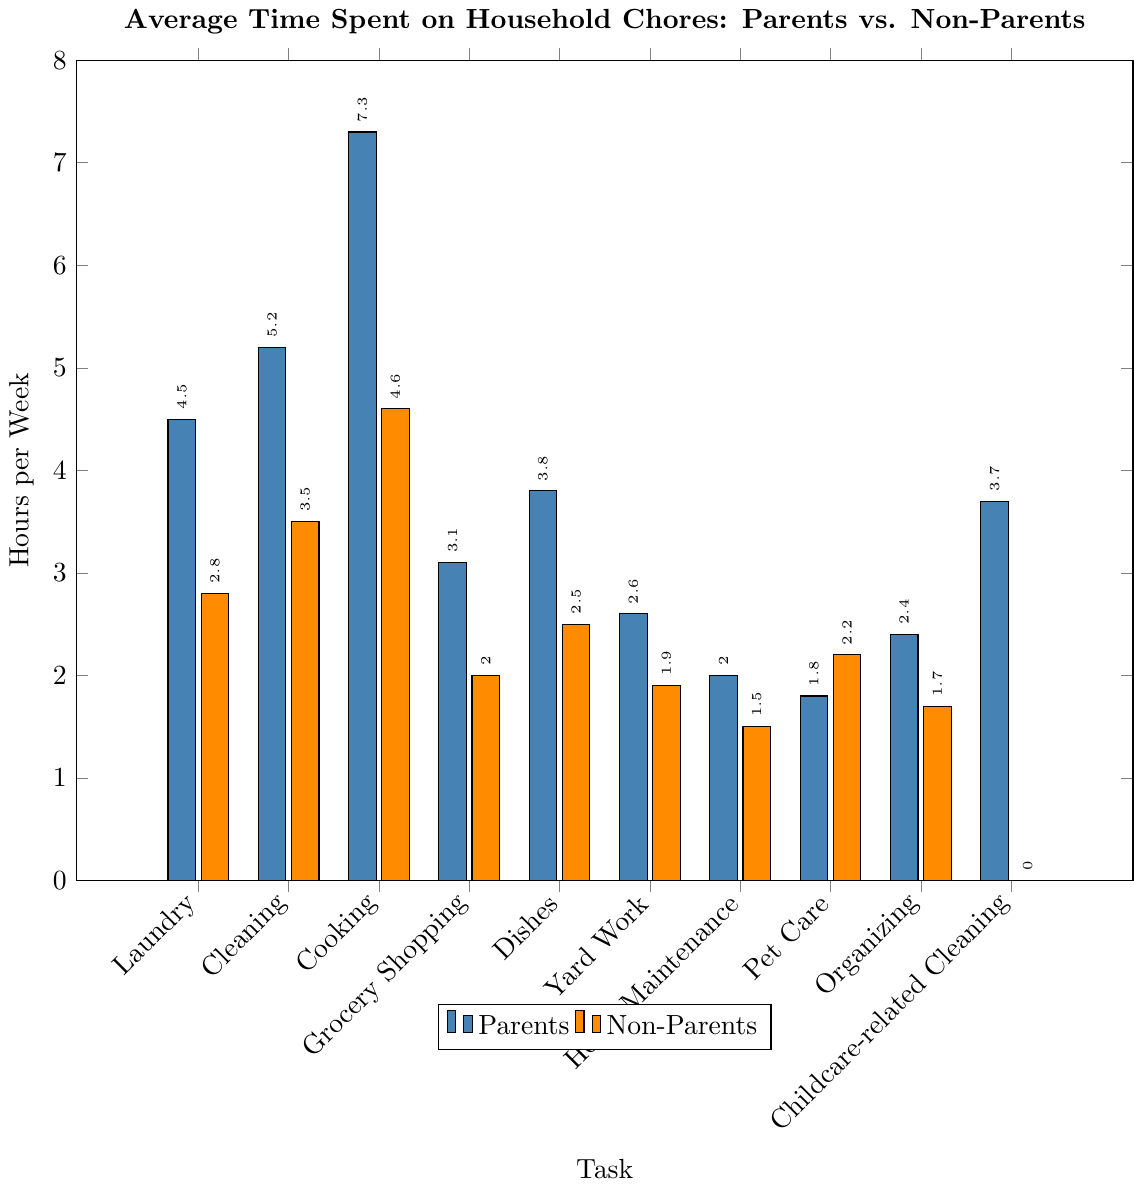Which task has the highest average time spent by parents? By looking at the figure, the bar for cooking among parents has the greatest height compared to other tasks.
Answer: Cooking What is the difference in time spent on laundry between parents and non-parents? The figure shows that parents spend 4.5 hours per week, and non-parents spend 2.8 hours per week on laundry. The difference is 4.5 - 2.8 = 1.7 hours.
Answer: 1.7 hours Which tasks do non-parents spend more time on than parents? By comparing the heights of the bars, it is observed that non-parents spend more time on pet care compared to parents.
Answer: Pet care How much more time do parents spend on cleaning compared to non-parents? The time spent on cleaning by parents is 5.2 hours and by non-parents is 3.5 hours. The difference is 5.2 - 3.5 = 1.7 hours.
Answer: 1.7 hours Which group spends more time on dishes, and by how much? The figure shows that parents spend 3.8 hours on dishes, while non-parents spend 2.5 hours. The difference is 3.8 - 2.5 = 1.3 hours, showing that parents spend more time.
Answer: Parents by 1.3 hours Total time spent by parents on all tasks except pet care and childcare-related cleaning? Adding the hours for all tasks except pet care and childcare-related cleaning: 4.5 (laundry) + 5.2 (cleaning) + 7.3 (cooking) + 3.1 (grocery shopping) + 3.8 (dishes) + 2.6 (yard work) + 2.0 (home maintenance) + 2.4 (organizing) = 30.9 hours.
Answer: 30.9 hours Which group spends less time on home maintenance, and what's the exact difference? From the figure, parents spend 2.0 hours and non-parents spend 1.5 hours on home maintenance. Parents spend more; the difference is 2.0 - 1.5 = 0.5 hours.
Answer: Non-parents by 0.5 hours What is the average time spent on cooking and dishes by parents? The time spent on cooking is 7.3 hours and on dishes is 3.8 hours. The average is (7.3 + 3.8) / 2 = 5.55 hours.
Answer: 5.55 hours 